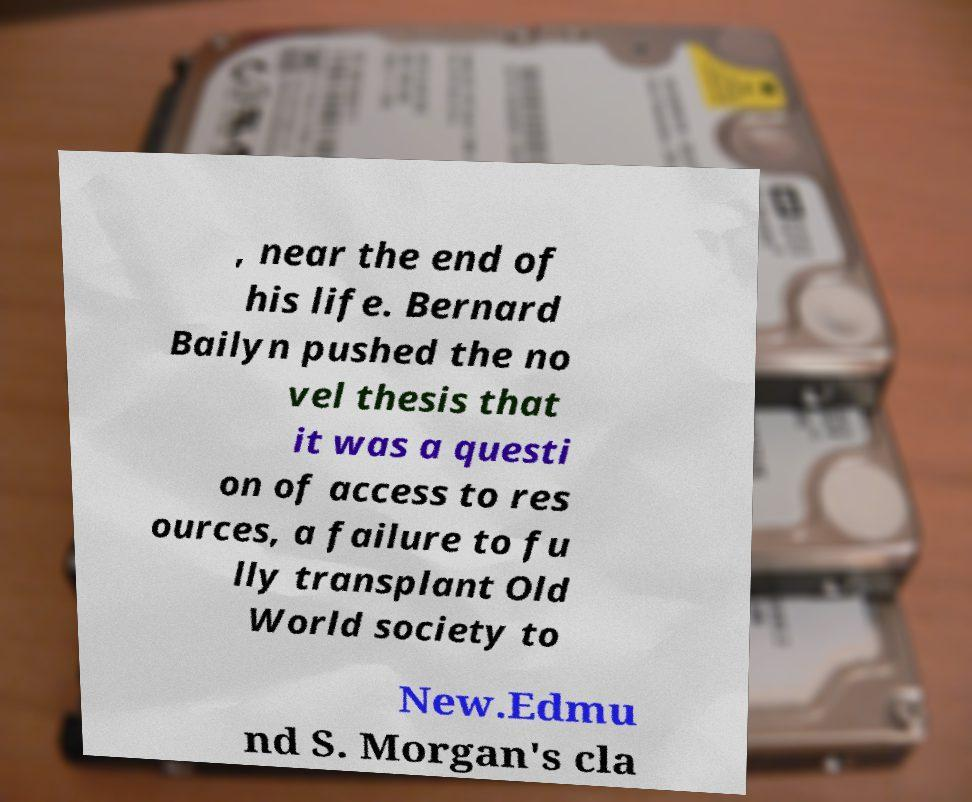Please read and relay the text visible in this image. What does it say? , near the end of his life. Bernard Bailyn pushed the no vel thesis that it was a questi on of access to res ources, a failure to fu lly transplant Old World society to New.Edmu nd S. Morgan's cla 